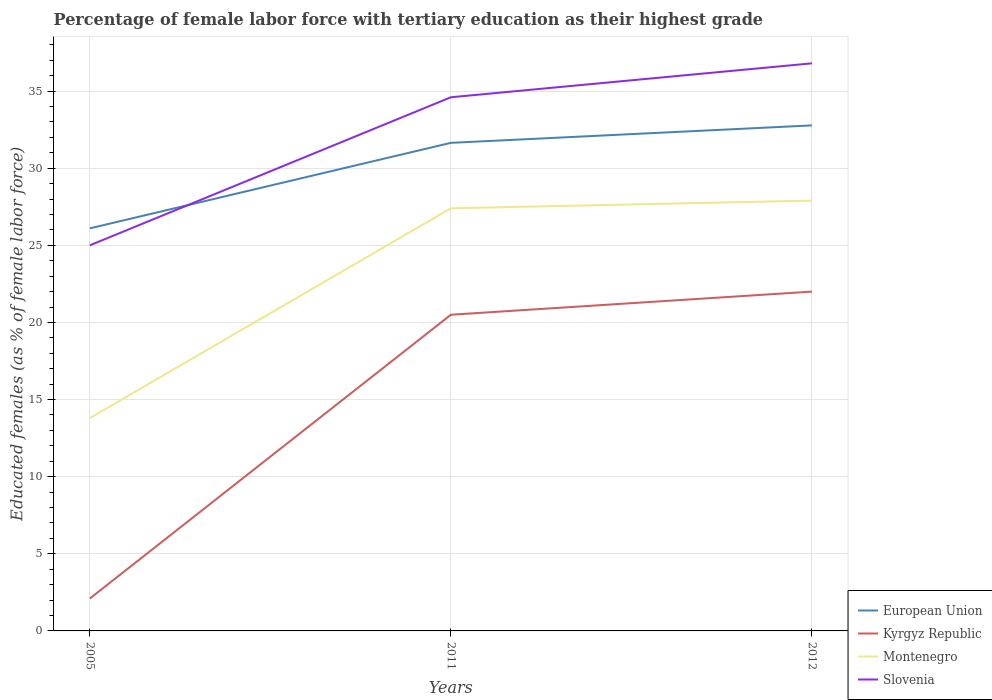How many different coloured lines are there?
Your answer should be very brief. 4. Does the line corresponding to Kyrgyz Republic intersect with the line corresponding to Slovenia?
Provide a short and direct response. No. Is the number of lines equal to the number of legend labels?
Your answer should be very brief. Yes. Across all years, what is the maximum percentage of female labor force with tertiary education in Kyrgyz Republic?
Give a very brief answer. 2.1. In which year was the percentage of female labor force with tertiary education in European Union maximum?
Give a very brief answer. 2005. What is the total percentage of female labor force with tertiary education in Montenegro in the graph?
Make the answer very short. -13.6. What is the difference between the highest and the second highest percentage of female labor force with tertiary education in European Union?
Ensure brevity in your answer.  6.68. What is the difference between the highest and the lowest percentage of female labor force with tertiary education in Slovenia?
Offer a terse response. 2. Is the percentage of female labor force with tertiary education in Kyrgyz Republic strictly greater than the percentage of female labor force with tertiary education in European Union over the years?
Give a very brief answer. Yes. How many lines are there?
Provide a short and direct response. 4. How many years are there in the graph?
Your response must be concise. 3. Are the values on the major ticks of Y-axis written in scientific E-notation?
Give a very brief answer. No. Does the graph contain any zero values?
Your answer should be very brief. No. How are the legend labels stacked?
Offer a very short reply. Vertical. What is the title of the graph?
Offer a very short reply. Percentage of female labor force with tertiary education as their highest grade. Does "Turks and Caicos Islands" appear as one of the legend labels in the graph?
Your answer should be very brief. No. What is the label or title of the X-axis?
Your response must be concise. Years. What is the label or title of the Y-axis?
Your answer should be compact. Educated females (as % of female labor force). What is the Educated females (as % of female labor force) of European Union in 2005?
Offer a terse response. 26.1. What is the Educated females (as % of female labor force) of Kyrgyz Republic in 2005?
Make the answer very short. 2.1. What is the Educated females (as % of female labor force) in Montenegro in 2005?
Offer a very short reply. 13.8. What is the Educated females (as % of female labor force) in Slovenia in 2005?
Provide a succinct answer. 25. What is the Educated females (as % of female labor force) of European Union in 2011?
Give a very brief answer. 31.65. What is the Educated females (as % of female labor force) in Montenegro in 2011?
Your answer should be compact. 27.4. What is the Educated females (as % of female labor force) in Slovenia in 2011?
Keep it short and to the point. 34.6. What is the Educated females (as % of female labor force) in European Union in 2012?
Give a very brief answer. 32.78. What is the Educated females (as % of female labor force) of Kyrgyz Republic in 2012?
Offer a terse response. 22. What is the Educated females (as % of female labor force) of Montenegro in 2012?
Your answer should be compact. 27.9. What is the Educated females (as % of female labor force) in Slovenia in 2012?
Offer a very short reply. 36.8. Across all years, what is the maximum Educated females (as % of female labor force) of European Union?
Keep it short and to the point. 32.78. Across all years, what is the maximum Educated females (as % of female labor force) in Kyrgyz Republic?
Keep it short and to the point. 22. Across all years, what is the maximum Educated females (as % of female labor force) in Montenegro?
Your response must be concise. 27.9. Across all years, what is the maximum Educated females (as % of female labor force) in Slovenia?
Ensure brevity in your answer.  36.8. Across all years, what is the minimum Educated females (as % of female labor force) in European Union?
Offer a terse response. 26.1. Across all years, what is the minimum Educated females (as % of female labor force) of Kyrgyz Republic?
Make the answer very short. 2.1. Across all years, what is the minimum Educated females (as % of female labor force) of Montenegro?
Make the answer very short. 13.8. Across all years, what is the minimum Educated females (as % of female labor force) in Slovenia?
Provide a succinct answer. 25. What is the total Educated females (as % of female labor force) in European Union in the graph?
Provide a short and direct response. 90.52. What is the total Educated females (as % of female labor force) in Kyrgyz Republic in the graph?
Your answer should be very brief. 44.6. What is the total Educated females (as % of female labor force) in Montenegro in the graph?
Give a very brief answer. 69.1. What is the total Educated females (as % of female labor force) of Slovenia in the graph?
Make the answer very short. 96.4. What is the difference between the Educated females (as % of female labor force) of European Union in 2005 and that in 2011?
Offer a very short reply. -5.54. What is the difference between the Educated females (as % of female labor force) in Kyrgyz Republic in 2005 and that in 2011?
Ensure brevity in your answer.  -18.4. What is the difference between the Educated females (as % of female labor force) in European Union in 2005 and that in 2012?
Provide a short and direct response. -6.68. What is the difference between the Educated females (as % of female labor force) in Kyrgyz Republic in 2005 and that in 2012?
Offer a terse response. -19.9. What is the difference between the Educated females (as % of female labor force) in Montenegro in 2005 and that in 2012?
Your response must be concise. -14.1. What is the difference between the Educated females (as % of female labor force) of European Union in 2011 and that in 2012?
Your answer should be compact. -1.13. What is the difference between the Educated females (as % of female labor force) of Kyrgyz Republic in 2011 and that in 2012?
Your response must be concise. -1.5. What is the difference between the Educated females (as % of female labor force) of European Union in 2005 and the Educated females (as % of female labor force) of Kyrgyz Republic in 2011?
Provide a succinct answer. 5.6. What is the difference between the Educated females (as % of female labor force) of European Union in 2005 and the Educated females (as % of female labor force) of Montenegro in 2011?
Your response must be concise. -1.3. What is the difference between the Educated females (as % of female labor force) of European Union in 2005 and the Educated females (as % of female labor force) of Slovenia in 2011?
Ensure brevity in your answer.  -8.5. What is the difference between the Educated females (as % of female labor force) in Kyrgyz Republic in 2005 and the Educated females (as % of female labor force) in Montenegro in 2011?
Ensure brevity in your answer.  -25.3. What is the difference between the Educated females (as % of female labor force) of Kyrgyz Republic in 2005 and the Educated females (as % of female labor force) of Slovenia in 2011?
Your response must be concise. -32.5. What is the difference between the Educated females (as % of female labor force) of Montenegro in 2005 and the Educated females (as % of female labor force) of Slovenia in 2011?
Keep it short and to the point. -20.8. What is the difference between the Educated females (as % of female labor force) in European Union in 2005 and the Educated females (as % of female labor force) in Kyrgyz Republic in 2012?
Your response must be concise. 4.1. What is the difference between the Educated females (as % of female labor force) of European Union in 2005 and the Educated females (as % of female labor force) of Montenegro in 2012?
Make the answer very short. -1.8. What is the difference between the Educated females (as % of female labor force) in European Union in 2005 and the Educated females (as % of female labor force) in Slovenia in 2012?
Give a very brief answer. -10.7. What is the difference between the Educated females (as % of female labor force) in Kyrgyz Republic in 2005 and the Educated females (as % of female labor force) in Montenegro in 2012?
Your answer should be very brief. -25.8. What is the difference between the Educated females (as % of female labor force) in Kyrgyz Republic in 2005 and the Educated females (as % of female labor force) in Slovenia in 2012?
Provide a short and direct response. -34.7. What is the difference between the Educated females (as % of female labor force) of European Union in 2011 and the Educated females (as % of female labor force) of Kyrgyz Republic in 2012?
Your response must be concise. 9.64. What is the difference between the Educated females (as % of female labor force) of European Union in 2011 and the Educated females (as % of female labor force) of Montenegro in 2012?
Ensure brevity in your answer.  3.75. What is the difference between the Educated females (as % of female labor force) in European Union in 2011 and the Educated females (as % of female labor force) in Slovenia in 2012?
Provide a short and direct response. -5.16. What is the difference between the Educated females (as % of female labor force) in Kyrgyz Republic in 2011 and the Educated females (as % of female labor force) in Slovenia in 2012?
Give a very brief answer. -16.3. What is the difference between the Educated females (as % of female labor force) of Montenegro in 2011 and the Educated females (as % of female labor force) of Slovenia in 2012?
Offer a terse response. -9.4. What is the average Educated females (as % of female labor force) of European Union per year?
Your answer should be very brief. 30.17. What is the average Educated females (as % of female labor force) of Kyrgyz Republic per year?
Offer a very short reply. 14.87. What is the average Educated females (as % of female labor force) in Montenegro per year?
Provide a short and direct response. 23.03. What is the average Educated females (as % of female labor force) in Slovenia per year?
Ensure brevity in your answer.  32.13. In the year 2005, what is the difference between the Educated females (as % of female labor force) of European Union and Educated females (as % of female labor force) of Kyrgyz Republic?
Provide a short and direct response. 24. In the year 2005, what is the difference between the Educated females (as % of female labor force) in European Union and Educated females (as % of female labor force) in Montenegro?
Offer a very short reply. 12.3. In the year 2005, what is the difference between the Educated females (as % of female labor force) of European Union and Educated females (as % of female labor force) of Slovenia?
Offer a terse response. 1.1. In the year 2005, what is the difference between the Educated females (as % of female labor force) in Kyrgyz Republic and Educated females (as % of female labor force) in Slovenia?
Make the answer very short. -22.9. In the year 2011, what is the difference between the Educated females (as % of female labor force) in European Union and Educated females (as % of female labor force) in Kyrgyz Republic?
Make the answer very short. 11.14. In the year 2011, what is the difference between the Educated females (as % of female labor force) of European Union and Educated females (as % of female labor force) of Montenegro?
Keep it short and to the point. 4.25. In the year 2011, what is the difference between the Educated females (as % of female labor force) of European Union and Educated females (as % of female labor force) of Slovenia?
Your answer should be very brief. -2.96. In the year 2011, what is the difference between the Educated females (as % of female labor force) of Kyrgyz Republic and Educated females (as % of female labor force) of Montenegro?
Your answer should be very brief. -6.9. In the year 2011, what is the difference between the Educated females (as % of female labor force) in Kyrgyz Republic and Educated females (as % of female labor force) in Slovenia?
Ensure brevity in your answer.  -14.1. In the year 2011, what is the difference between the Educated females (as % of female labor force) of Montenegro and Educated females (as % of female labor force) of Slovenia?
Your answer should be very brief. -7.2. In the year 2012, what is the difference between the Educated females (as % of female labor force) in European Union and Educated females (as % of female labor force) in Kyrgyz Republic?
Your answer should be very brief. 10.78. In the year 2012, what is the difference between the Educated females (as % of female labor force) of European Union and Educated females (as % of female labor force) of Montenegro?
Give a very brief answer. 4.88. In the year 2012, what is the difference between the Educated females (as % of female labor force) in European Union and Educated females (as % of female labor force) in Slovenia?
Keep it short and to the point. -4.02. In the year 2012, what is the difference between the Educated females (as % of female labor force) in Kyrgyz Republic and Educated females (as % of female labor force) in Slovenia?
Give a very brief answer. -14.8. What is the ratio of the Educated females (as % of female labor force) in European Union in 2005 to that in 2011?
Give a very brief answer. 0.82. What is the ratio of the Educated females (as % of female labor force) of Kyrgyz Republic in 2005 to that in 2011?
Keep it short and to the point. 0.1. What is the ratio of the Educated females (as % of female labor force) of Montenegro in 2005 to that in 2011?
Your response must be concise. 0.5. What is the ratio of the Educated females (as % of female labor force) of Slovenia in 2005 to that in 2011?
Give a very brief answer. 0.72. What is the ratio of the Educated females (as % of female labor force) in European Union in 2005 to that in 2012?
Ensure brevity in your answer.  0.8. What is the ratio of the Educated females (as % of female labor force) in Kyrgyz Republic in 2005 to that in 2012?
Provide a succinct answer. 0.1. What is the ratio of the Educated females (as % of female labor force) of Montenegro in 2005 to that in 2012?
Ensure brevity in your answer.  0.49. What is the ratio of the Educated females (as % of female labor force) in Slovenia in 2005 to that in 2012?
Your response must be concise. 0.68. What is the ratio of the Educated females (as % of female labor force) in European Union in 2011 to that in 2012?
Offer a very short reply. 0.97. What is the ratio of the Educated females (as % of female labor force) in Kyrgyz Republic in 2011 to that in 2012?
Offer a very short reply. 0.93. What is the ratio of the Educated females (as % of female labor force) in Montenegro in 2011 to that in 2012?
Your response must be concise. 0.98. What is the ratio of the Educated females (as % of female labor force) in Slovenia in 2011 to that in 2012?
Offer a very short reply. 0.94. What is the difference between the highest and the second highest Educated females (as % of female labor force) in European Union?
Give a very brief answer. 1.13. What is the difference between the highest and the second highest Educated females (as % of female labor force) in Kyrgyz Republic?
Keep it short and to the point. 1.5. What is the difference between the highest and the second highest Educated females (as % of female labor force) of Montenegro?
Give a very brief answer. 0.5. What is the difference between the highest and the second highest Educated females (as % of female labor force) in Slovenia?
Make the answer very short. 2.2. What is the difference between the highest and the lowest Educated females (as % of female labor force) in European Union?
Your response must be concise. 6.68. What is the difference between the highest and the lowest Educated females (as % of female labor force) of Montenegro?
Keep it short and to the point. 14.1. 